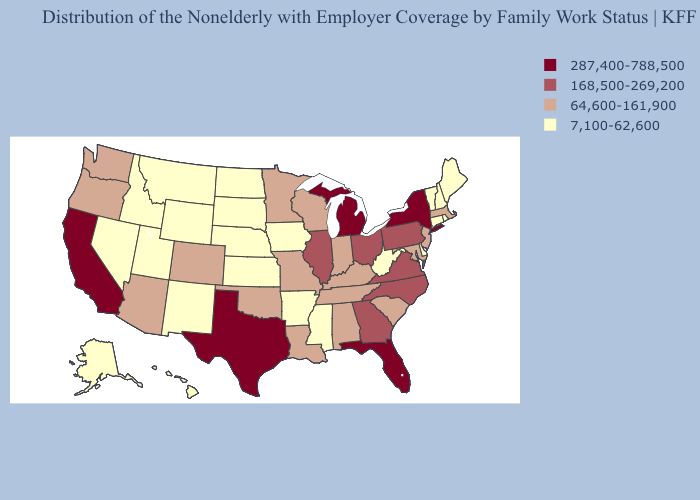What is the highest value in the South ?
Give a very brief answer. 287,400-788,500. Does New Hampshire have the highest value in the Northeast?
Answer briefly. No. Does Wyoming have the same value as Nebraska?
Short answer required. Yes. What is the value of Idaho?
Concise answer only. 7,100-62,600. What is the highest value in the Northeast ?
Answer briefly. 287,400-788,500. How many symbols are there in the legend?
Short answer required. 4. What is the highest value in the USA?
Be succinct. 287,400-788,500. What is the highest value in the USA?
Short answer required. 287,400-788,500. Name the states that have a value in the range 64,600-161,900?
Keep it brief. Alabama, Arizona, Colorado, Indiana, Kentucky, Louisiana, Maryland, Massachusetts, Minnesota, Missouri, New Jersey, Oklahoma, Oregon, South Carolina, Tennessee, Washington, Wisconsin. Which states have the lowest value in the MidWest?
Quick response, please. Iowa, Kansas, Nebraska, North Dakota, South Dakota. Does Arkansas have the lowest value in the South?
Concise answer only. Yes. Does the first symbol in the legend represent the smallest category?
Be succinct. No. Does the map have missing data?
Be succinct. No. What is the value of Colorado?
Answer briefly. 64,600-161,900. What is the lowest value in the USA?
Be succinct. 7,100-62,600. 